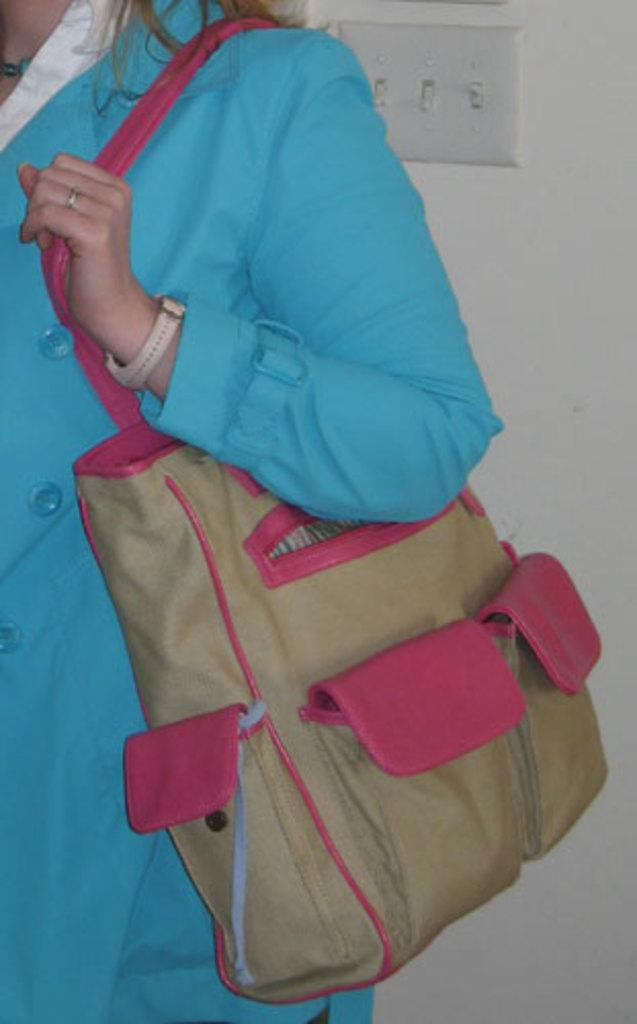Who is present in the image? There is a woman in the image. What is the woman wearing? The woman is wearing a blue dress. What is the woman holding in the image? The woman is holding a bag. How many rabbits are sitting on the sofa in the image? There are no rabbits or sofa present in the image. 